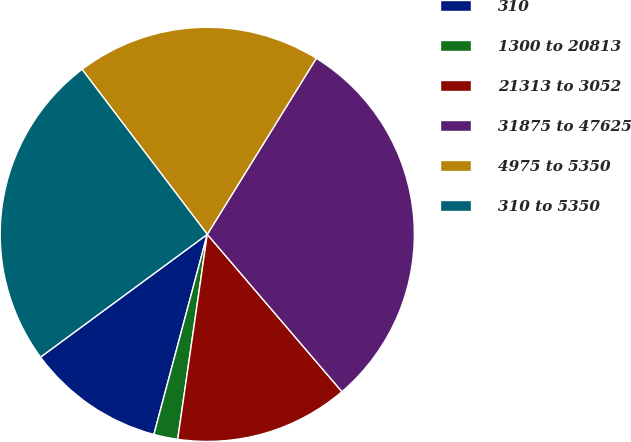Convert chart to OTSL. <chart><loc_0><loc_0><loc_500><loc_500><pie_chart><fcel>310<fcel>1300 to 20813<fcel>21313 to 3052<fcel>31875 to 47625<fcel>4975 to 5350<fcel>310 to 5350<nl><fcel>10.75%<fcel>1.87%<fcel>13.55%<fcel>29.91%<fcel>19.16%<fcel>24.77%<nl></chart> 